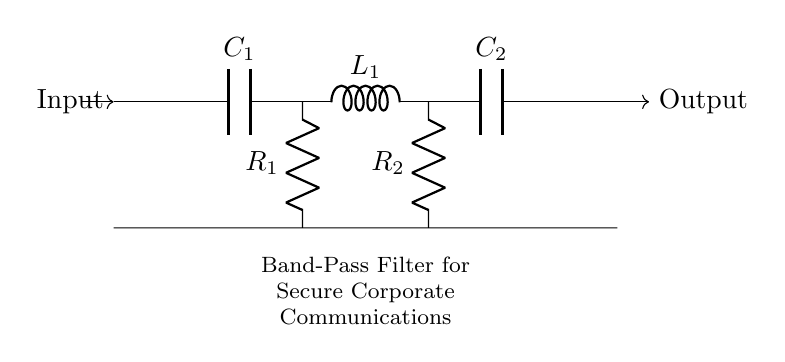What are the components in the circuit? The circuit comprises two capacitors, two resistors, and one inductor. Each component is labeled in the diagram showing their respective positions.
Answer: Capacitors, resistors, inductor What is the purpose of the filter? The circuit is designed as a band-pass filter specifically for secure corporate communications, allowing certain frequencies to pass while blocking others.
Answer: Secure communications How many resistors are present in the circuit? By examining the diagram, we see that there are two distinct resistors labeled R1 and R2, confirming the count.
Answer: Two What is the role of the capacitors in the circuit? The capacitors (C1 and C2) in the filter are used to block direct current (DC) while allowing alternating current (AC) signals of certain frequencies to pass, which is essential for the band-pass function.
Answer: Block DC, allow AC What is the order of the components in the filter? Moving from left to right in the diagram, the order is first a capacitor (C1), then an inductor (L1), followed by another capacitor (C2). This sequence is vital for achieving the desired filtering effect.
Answer: Capacitor, inductor, capacitor What is the total number of components in the circuit? There are a total of six components: two capacitors, two resistors, and one inductor, plus the connecting wires. Counting each one gives the total.
Answer: Six 